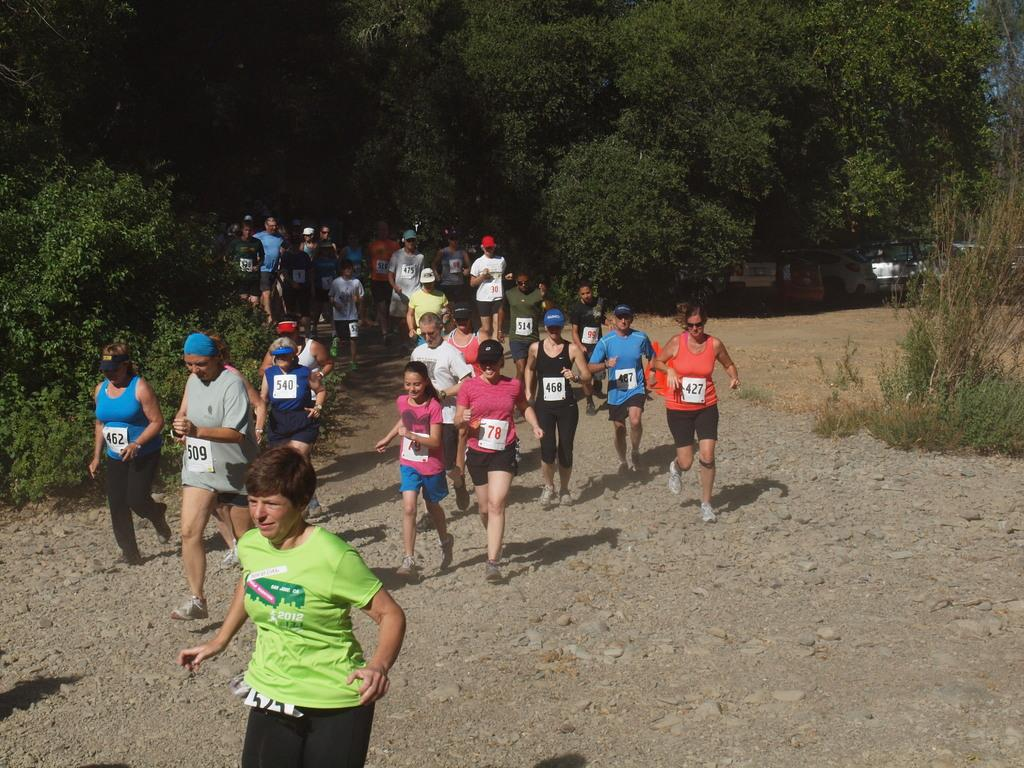What is happening in the center of the image? There are people in the center of the image, and they appear to be running. What can be seen in the background of the image? There are cars and trees in the background of the image. What type of pie is being sorted by the people in the image? There is no pie present in the image, nor are the people sorting anything. 